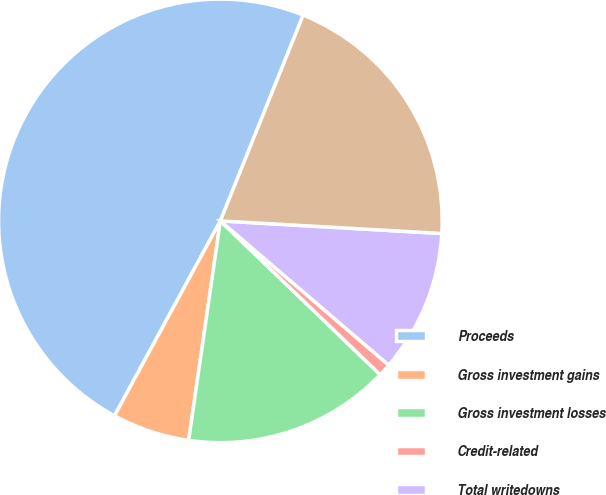Convert chart to OTSL. <chart><loc_0><loc_0><loc_500><loc_500><pie_chart><fcel>Proceeds<fcel>Gross investment gains<fcel>Gross investment losses<fcel>Credit-related<fcel>Total writedowns<fcel>Net investment gains (losses)<nl><fcel>48.17%<fcel>5.64%<fcel>15.09%<fcel>0.92%<fcel>10.37%<fcel>19.82%<nl></chart> 